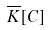Convert formula to latex. <formula><loc_0><loc_0><loc_500><loc_500>\overline { K } [ C ]</formula> 